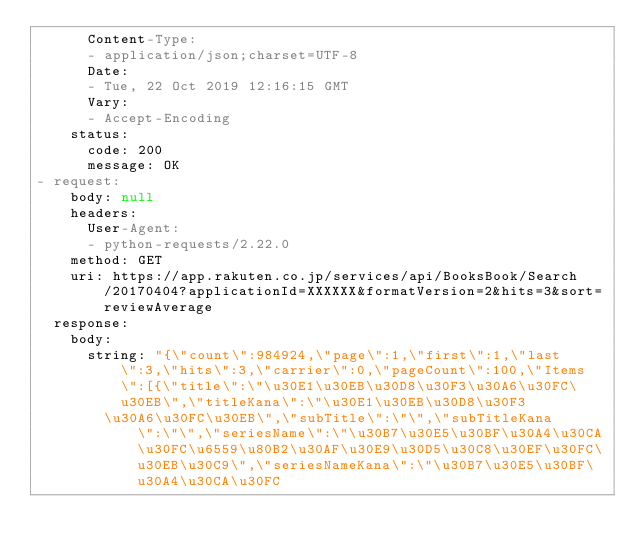Convert code to text. <code><loc_0><loc_0><loc_500><loc_500><_YAML_>      Content-Type:
      - application/json;charset=UTF-8
      Date:
      - Tue, 22 Oct 2019 12:16:15 GMT
      Vary:
      - Accept-Encoding
    status:
      code: 200
      message: OK
- request:
    body: null
    headers:
      User-Agent:
      - python-requests/2.22.0
    method: GET
    uri: https://app.rakuten.co.jp/services/api/BooksBook/Search/20170404?applicationId=XXXXXX&formatVersion=2&hits=3&sort=reviewAverage
  response:
    body:
      string: "{\"count\":984924,\"page\":1,\"first\":1,\"last\":3,\"hits\":3,\"carrier\":0,\"pageCount\":100,\"Items\":[{\"title\":\"\u30E1\u30EB\u30D8\u30F3\u30A6\u30FC\u30EB\",\"titleKana\":\"\u30E1\u30EB\u30D8\u30F3
        \u30A6\u30FC\u30EB\",\"subTitle\":\"\",\"subTitleKana\":\"\",\"seriesName\":\"\u30B7\u30E5\u30BF\u30A4\u30CA\u30FC\u6559\u80B2\u30AF\u30E9\u30D5\u30C8\u30EF\u30FC\u30EB\u30C9\",\"seriesNameKana\":\"\u30B7\u30E5\u30BF\u30A4\u30CA\u30FC</code> 